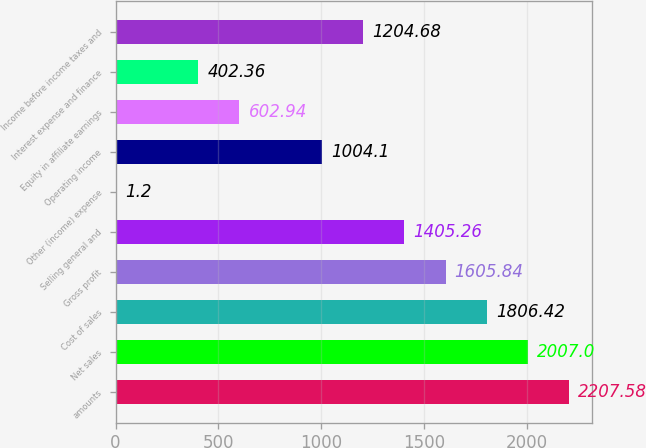Convert chart to OTSL. <chart><loc_0><loc_0><loc_500><loc_500><bar_chart><fcel>amounts<fcel>Net sales<fcel>Cost of sales<fcel>Gross profit<fcel>Selling general and<fcel>Other (income) expense<fcel>Operating income<fcel>Equity in affiliate earnings<fcel>Interest expense and finance<fcel>Income before income taxes and<nl><fcel>2207.58<fcel>2007<fcel>1806.42<fcel>1605.84<fcel>1405.26<fcel>1.2<fcel>1004.1<fcel>602.94<fcel>402.36<fcel>1204.68<nl></chart> 